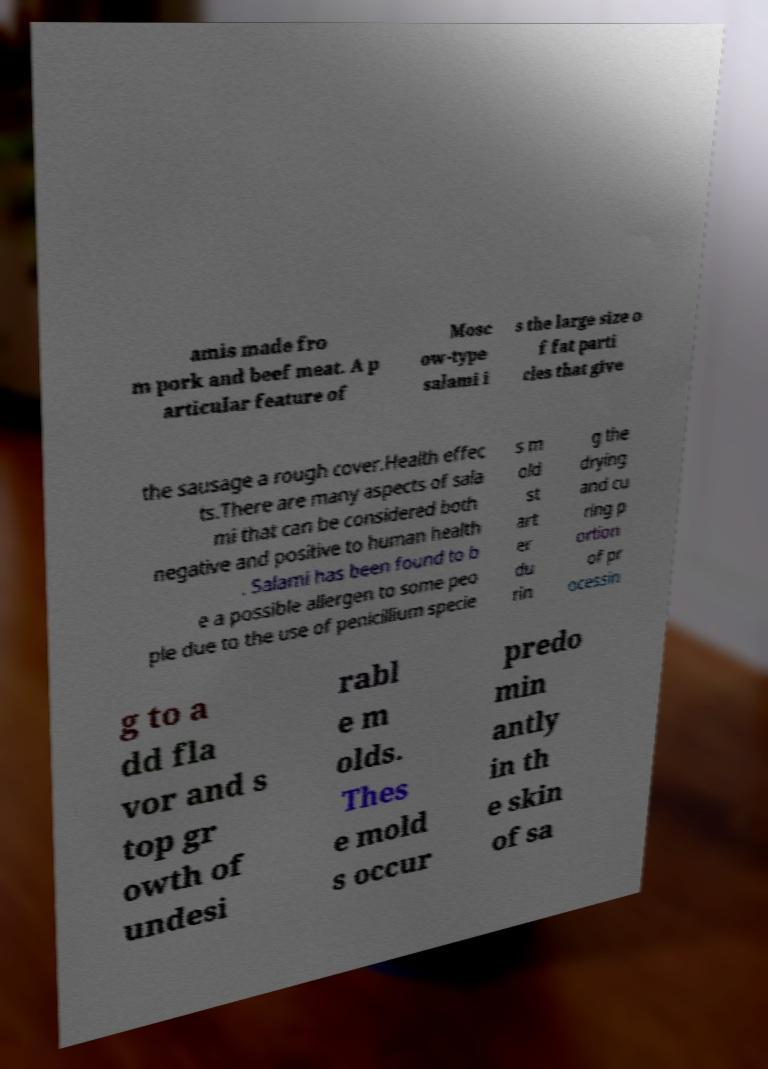I need the written content from this picture converted into text. Can you do that? amis made fro m pork and beef meat. A p articular feature of Mosc ow-type salami i s the large size o f fat parti cles that give the sausage a rough cover.Health effec ts.There are many aspects of sala mi that can be considered both negative and positive to human health . Salami has been found to b e a possible allergen to some peo ple due to the use of penicillium specie s m old st art er du rin g the drying and cu ring p ortion of pr ocessin g to a dd fla vor and s top gr owth of undesi rabl e m olds. Thes e mold s occur predo min antly in th e skin of sa 